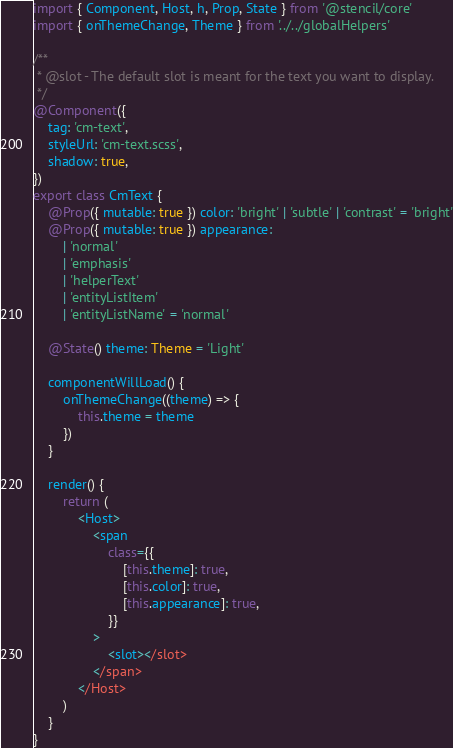Convert code to text. <code><loc_0><loc_0><loc_500><loc_500><_TypeScript_>import { Component, Host, h, Prop, State } from '@stencil/core'
import { onThemeChange, Theme } from '../../globalHelpers'

/**
 * @slot - The default slot is meant for the text you want to display.
 */
@Component({
	tag: 'cm-text',
	styleUrl: 'cm-text.scss',
	shadow: true,
})
export class CmText {
	@Prop({ mutable: true }) color: 'bright' | 'subtle' | 'contrast' = 'bright'
	@Prop({ mutable: true }) appearance:
		| 'normal'
		| 'emphasis'
		| 'helperText'
		| 'entityListItem'
		| 'entityListName' = 'normal'

	@State() theme: Theme = 'Light'

	componentWillLoad() {
		onThemeChange((theme) => {
			this.theme = theme
		})
	}

	render() {
		return (
			<Host>
				<span
					class={{
						[this.theme]: true,
						[this.color]: true,
						[this.appearance]: true,
					}}
				>
					<slot></slot>
				</span>
			</Host>
		)
	}
}
</code> 